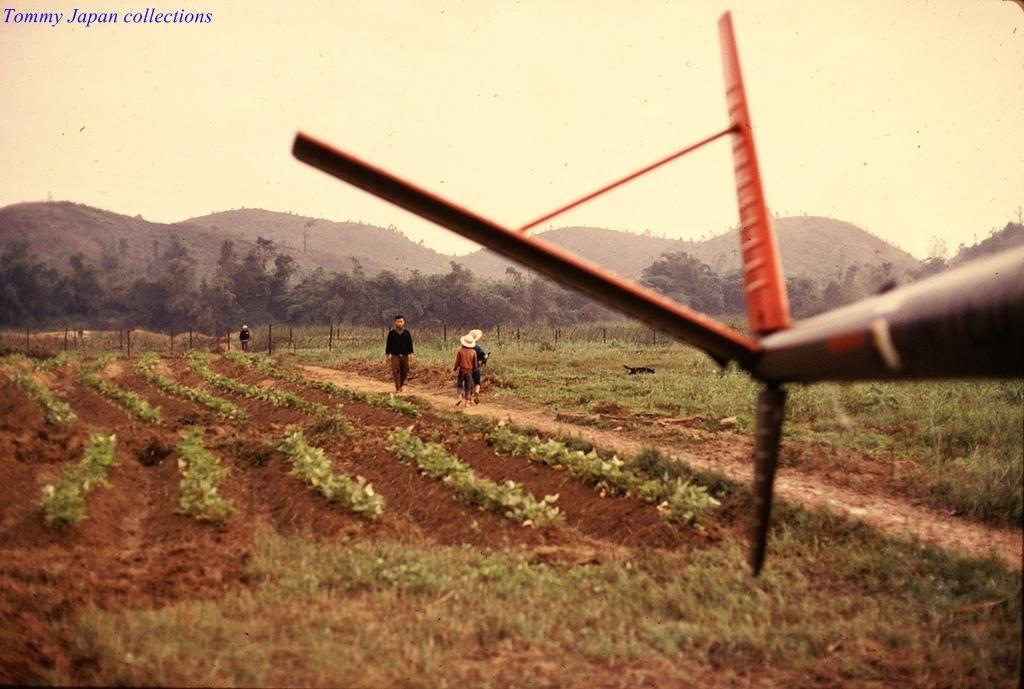Can you describe this image briefly? In this picture we can see fields at the bottom, there are some people walking in the middle, in the background there are some trees, we can see the sky at the top of the picture, there is some text at the left top of the picture, there is something present in the front. 